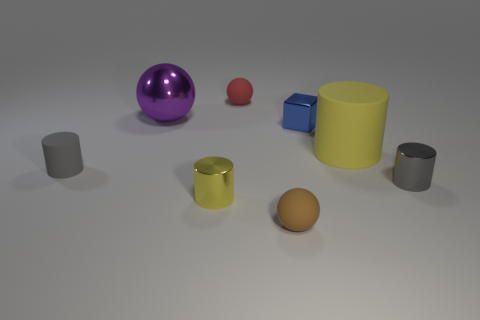Is the material of the tiny object to the left of the big purple metal thing the same as the small red object?
Provide a succinct answer. Yes. Is there a tiny metal cylinder that has the same color as the tiny rubber cylinder?
Offer a very short reply. Yes. What shape is the big purple object?
Ensure brevity in your answer.  Sphere. There is a tiny sphere behind the small rubber ball in front of the big purple metal object; what is its color?
Offer a very short reply. Red. There is a purple sphere behind the tiny gray rubber object; what size is it?
Give a very brief answer. Large. Is there a gray cylinder made of the same material as the tiny blue cube?
Provide a succinct answer. Yes. How many red objects have the same shape as the yellow matte thing?
Provide a short and direct response. 0. The matte thing that is behind the large purple ball behind the small metal cylinder on the right side of the brown object is what shape?
Offer a terse response. Sphere. The small thing that is both in front of the purple thing and behind the tiny gray rubber cylinder is made of what material?
Your answer should be very brief. Metal. There is a rubber cylinder that is to the left of the red ball; is it the same size as the tiny yellow object?
Your answer should be very brief. Yes. 